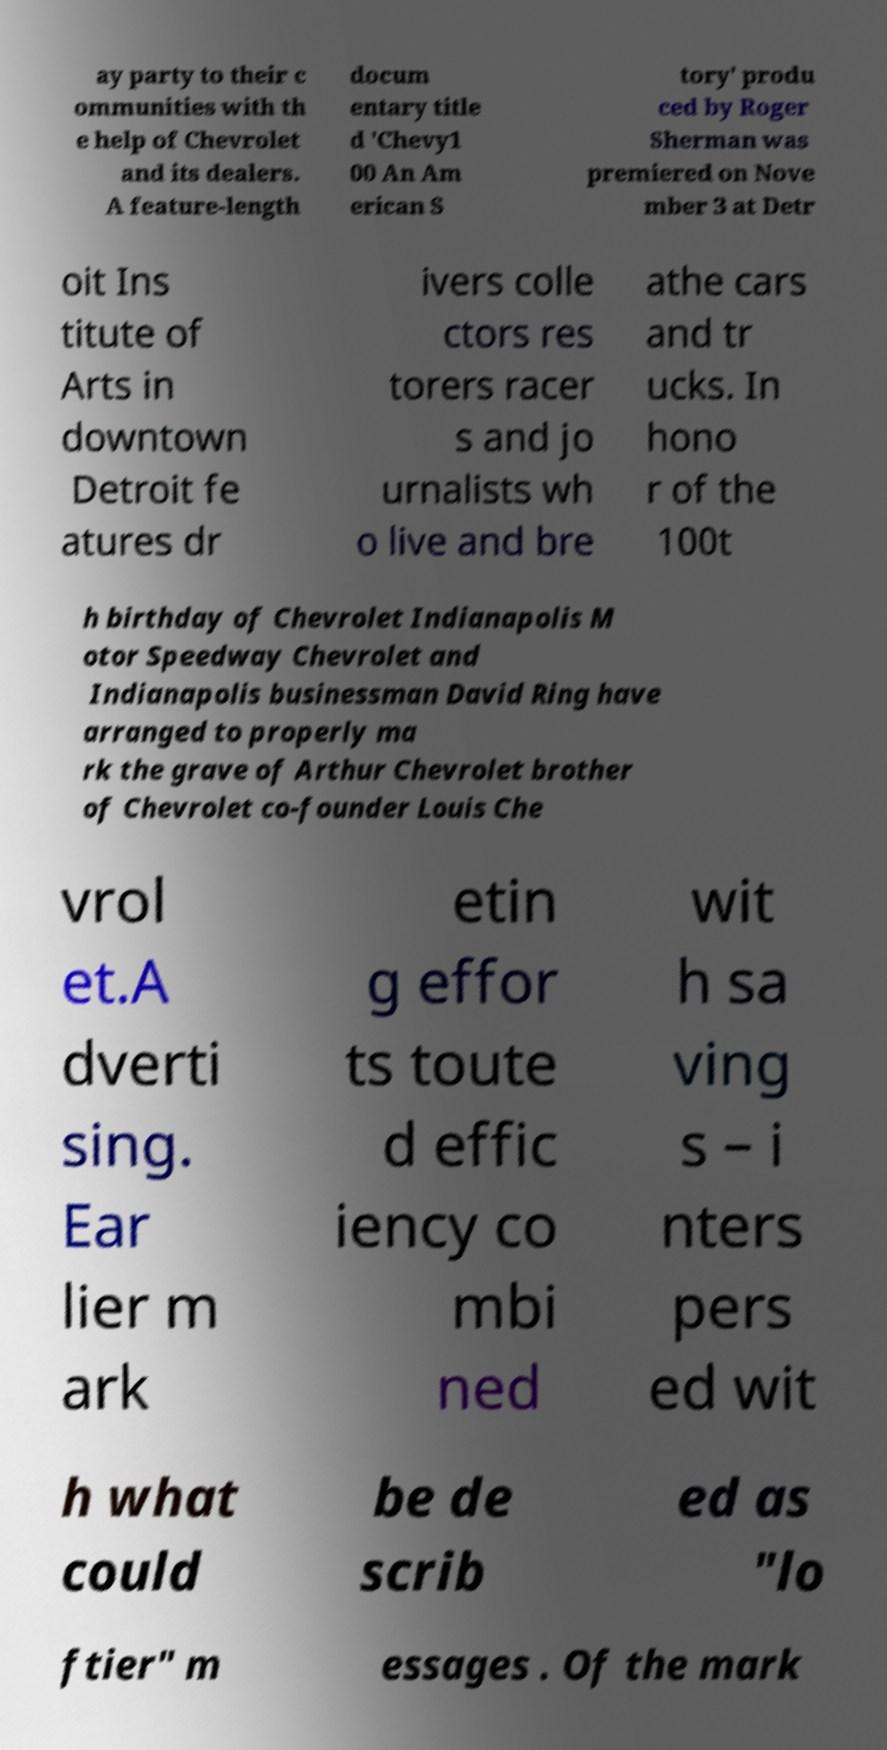Could you extract and type out the text from this image? ay party to their c ommunities with th e help of Chevrolet and its dealers. A feature-length docum entary title d 'Chevy1 00 An Am erican S tory' produ ced by Roger Sherman was premiered on Nove mber 3 at Detr oit Ins titute of Arts in downtown Detroit fe atures dr ivers colle ctors res torers racer s and jo urnalists wh o live and bre athe cars and tr ucks. In hono r of the 100t h birthday of Chevrolet Indianapolis M otor Speedway Chevrolet and Indianapolis businessman David Ring have arranged to properly ma rk the grave of Arthur Chevrolet brother of Chevrolet co-founder Louis Che vrol et.A dverti sing. Ear lier m ark etin g effor ts toute d effic iency co mbi ned wit h sa ving s – i nters pers ed wit h what could be de scrib ed as "lo ftier" m essages . Of the mark 